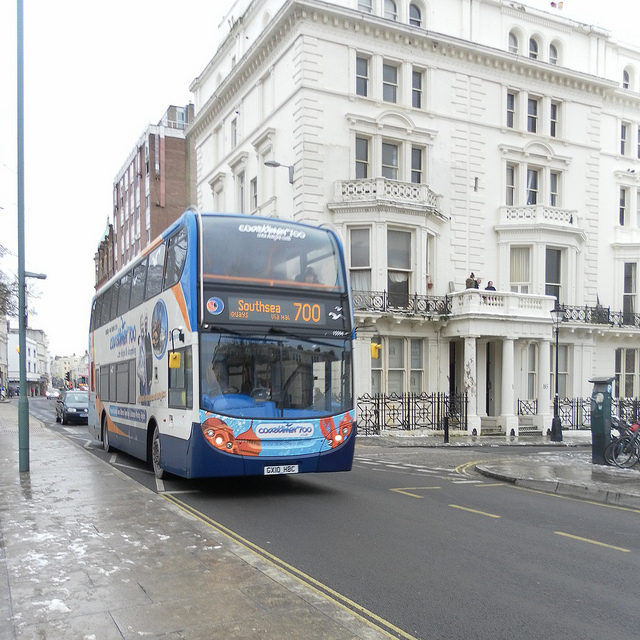<image>Where is this? It is unknown where this place is. It can be London or California. Where is this? I don't know where this is. It can be London or California. 